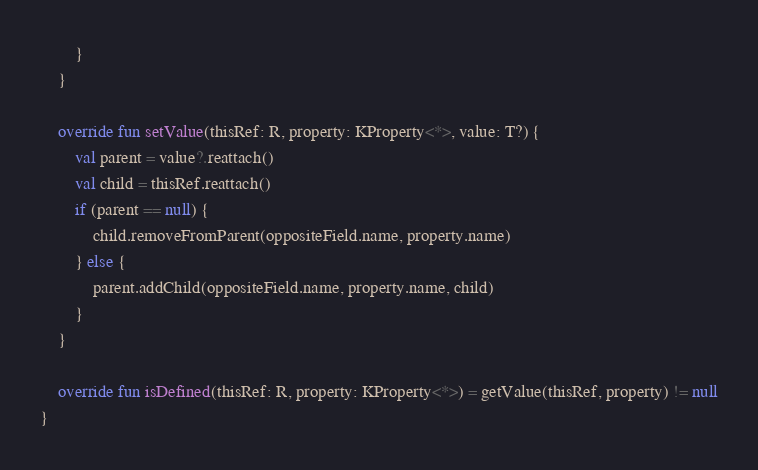Convert code to text. <code><loc_0><loc_0><loc_500><loc_500><_Kotlin_>        }
    }

    override fun setValue(thisRef: R, property: KProperty<*>, value: T?) {
        val parent = value?.reattach()
        val child = thisRef.reattach()
        if (parent == null) {
            child.removeFromParent(oppositeField.name, property.name)
        } else {
            parent.addChild(oppositeField.name, property.name, child)
        }
    }

    override fun isDefined(thisRef: R, property: KProperty<*>) = getValue(thisRef, property) != null
}

</code> 